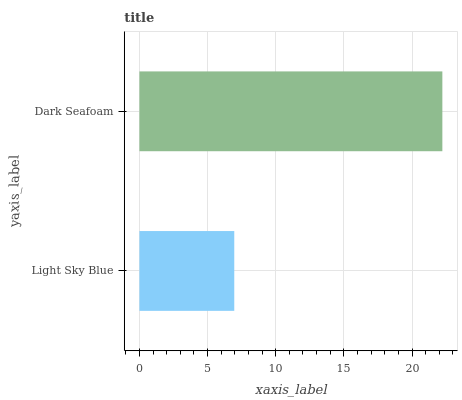Is Light Sky Blue the minimum?
Answer yes or no. Yes. Is Dark Seafoam the maximum?
Answer yes or no. Yes. Is Dark Seafoam the minimum?
Answer yes or no. No. Is Dark Seafoam greater than Light Sky Blue?
Answer yes or no. Yes. Is Light Sky Blue less than Dark Seafoam?
Answer yes or no. Yes. Is Light Sky Blue greater than Dark Seafoam?
Answer yes or no. No. Is Dark Seafoam less than Light Sky Blue?
Answer yes or no. No. Is Dark Seafoam the high median?
Answer yes or no. Yes. Is Light Sky Blue the low median?
Answer yes or no. Yes. Is Light Sky Blue the high median?
Answer yes or no. No. Is Dark Seafoam the low median?
Answer yes or no. No. 